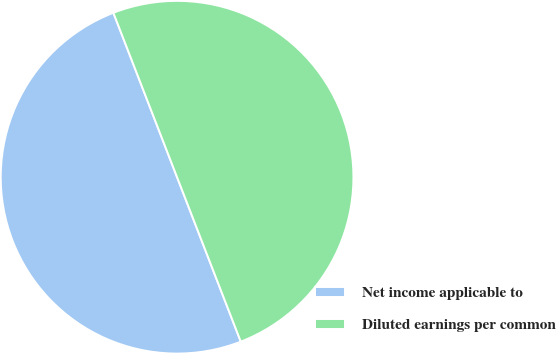<chart> <loc_0><loc_0><loc_500><loc_500><pie_chart><fcel>Net income applicable to<fcel>Diluted earnings per common<nl><fcel>50.0%<fcel>50.0%<nl></chart> 